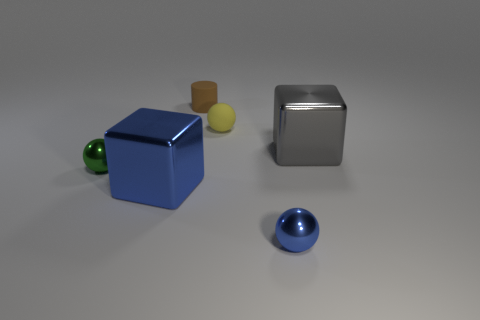Add 1 small green things. How many objects exist? 7 Subtract all blocks. How many objects are left? 4 Add 3 small yellow rubber balls. How many small yellow rubber balls are left? 4 Add 1 small yellow rubber things. How many small yellow rubber things exist? 2 Subtract 1 gray blocks. How many objects are left? 5 Subtract all yellow spheres. Subtract all blue shiny spheres. How many objects are left? 4 